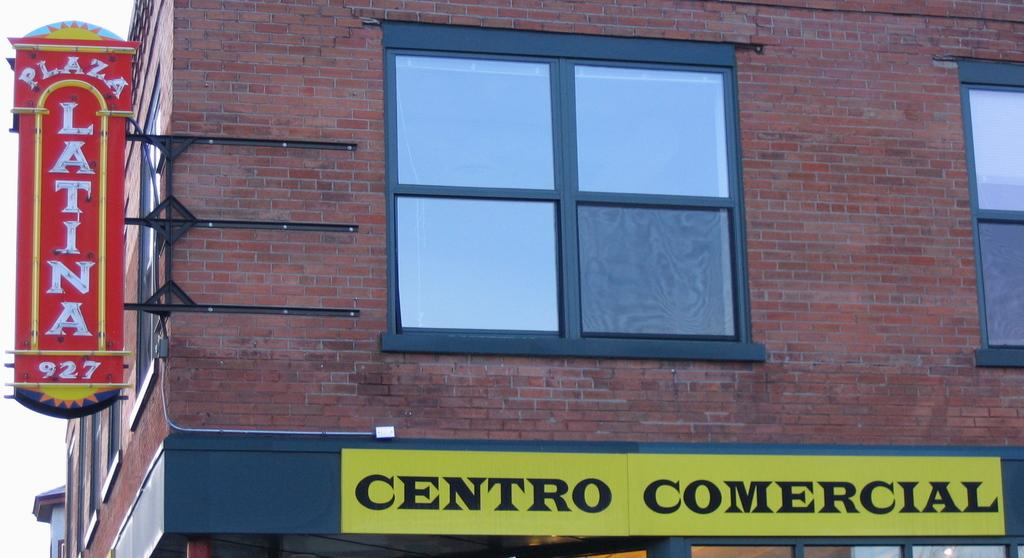What type of structure is visible in the image? There is a building in the image. Can you describe any specific features of the building? There is a window in the building. What else can be seen in the image besides the building? There is a stand with a board and another board, which is yellow in color. How do the boys control the van in the image? There are no boys or van present in the image. 